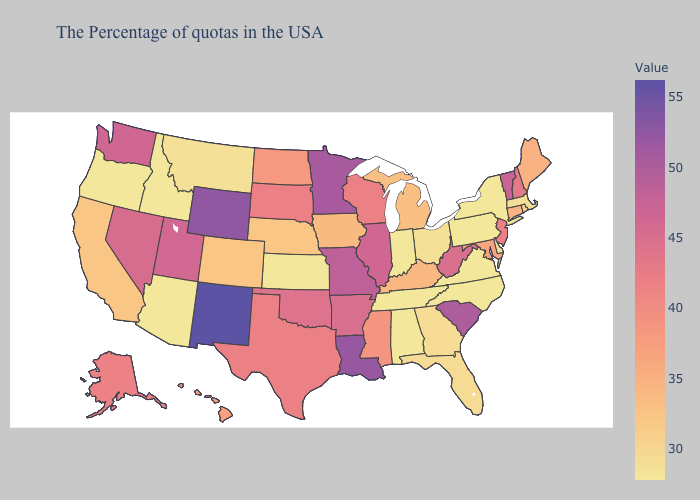Does Minnesota have the highest value in the MidWest?
Concise answer only. Yes. Which states hav the highest value in the Northeast?
Short answer required. Vermont. 